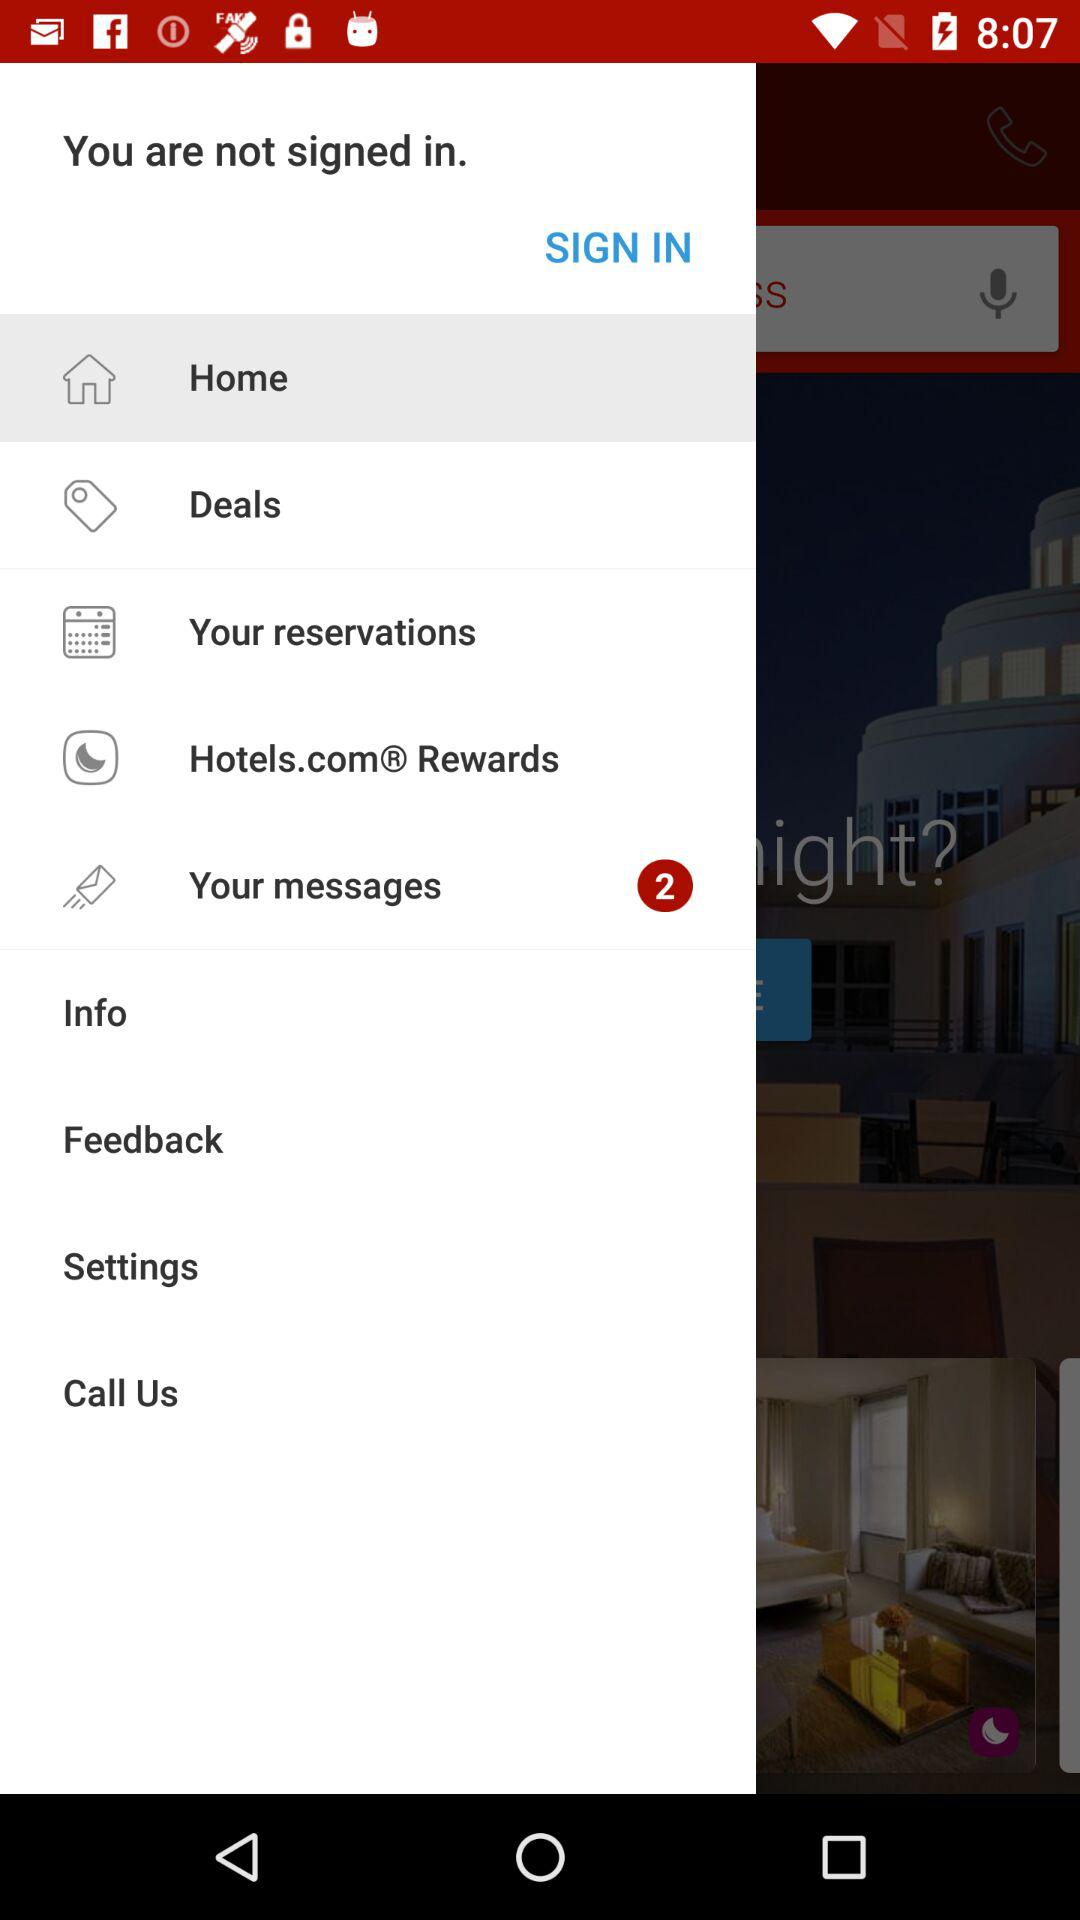How many unread messages are there? There are 2 unread messages. 